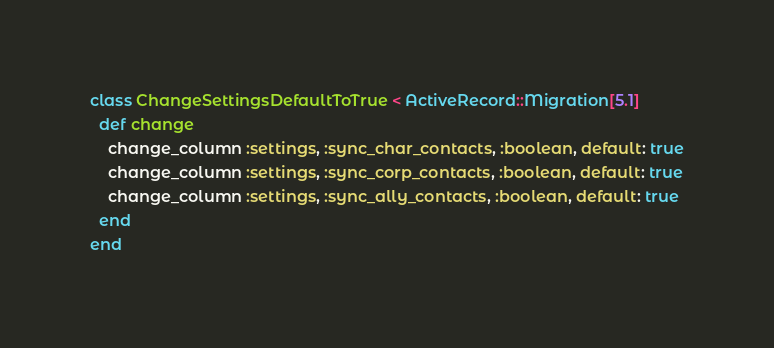Convert code to text. <code><loc_0><loc_0><loc_500><loc_500><_Ruby_>class ChangeSettingsDefaultToTrue < ActiveRecord::Migration[5.1]
  def change
    change_column :settings, :sync_char_contacts, :boolean, default: true
    change_column :settings, :sync_corp_contacts, :boolean, default: true
    change_column :settings, :sync_ally_contacts, :boolean, default: true
  end
end
</code> 